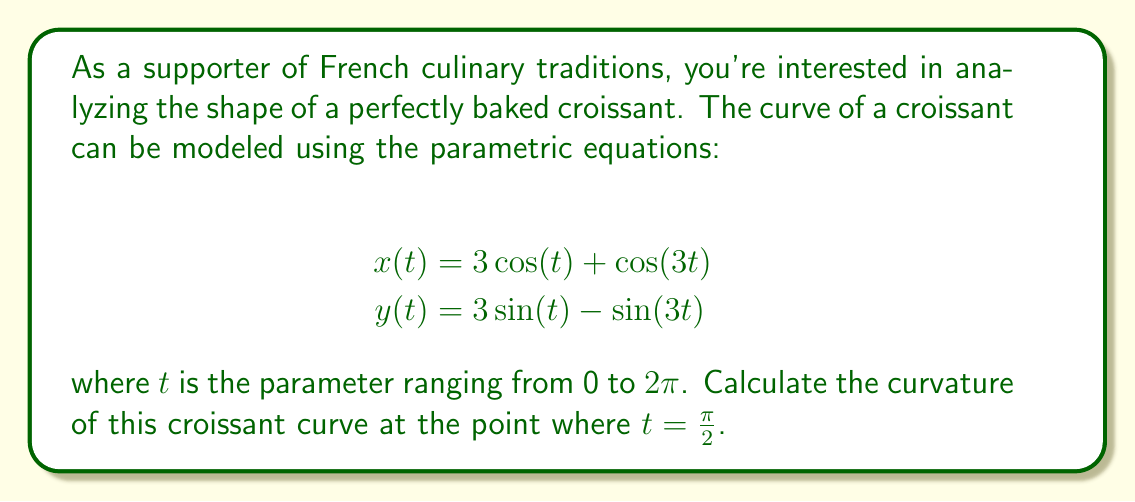Help me with this question. To find the curvature of a parametric curve at a given point, we can use the formula:

$$\kappa = \frac{|x'y'' - y'x''|}{(x'^2 + y'^2)^{3/2}}$$

where $x'$ and $y'$ are the first derivatives, and $x''$ and $y''$ are the second derivatives with respect to $t$.

Step 1: Calculate the first derivatives
$x'(t) = -3\sin(t) - 3\sin(3t)$
$y'(t) = 3\cos(t) - 3\cos(3t)$

Step 2: Calculate the second derivatives
$x''(t) = -3\cos(t) - 9\cos(3t)$
$y''(t) = -3\sin(t) + 9\sin(3t)$

Step 3: Evaluate the derivatives at $t = \frac{\pi}{2}$
$x'(\frac{\pi}{2}) = -3 - 3\sin(\frac{3\pi}{2}) = -3 + 3 = 0$
$y'(\frac{\pi}{2}) = 0 - 3\cos(\frac{3\pi}{2}) = 0 + 3 = 3$
$x''(\frac{\pi}{2}) = 0 - 9\cos(\frac{3\pi}{2}) = 0 + 9 = 9$
$y''(\frac{\pi}{2}) = -3 + 9\sin(\frac{3\pi}{2}) = -3 - 9 = -12$

Step 4: Apply the curvature formula
$$\kappa = \frac{|x'y'' - y'x''|}{(x'^2 + y'^2)^{3/2}}$$

$$\kappa = \frac{|(0)(-12) - (3)(9)|}{(0^2 + 3^2)^{3/2}}$$

$$\kappa = \frac{|-27|}{3^{3/2}} = \frac{27}{3\sqrt{3}} = \frac{9}{\sqrt{3}}$$

Therefore, the curvature of the croissant curve at $t = \frac{\pi}{2}$ is $\frac{9}{\sqrt{3}}$.
Answer: $\frac{9}{\sqrt{3}}$ 